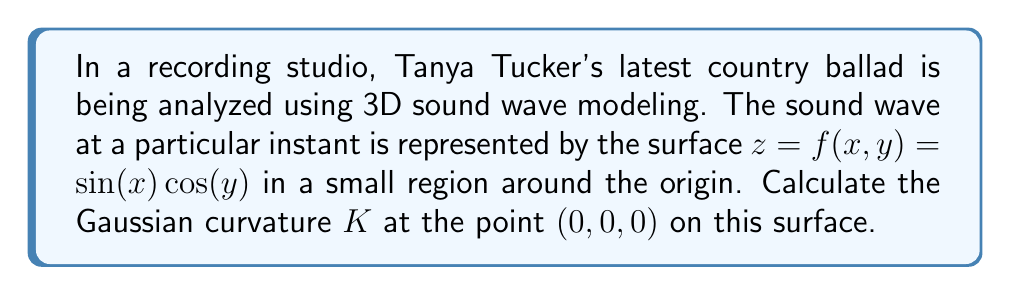Show me your answer to this math problem. To find the Gaussian curvature $K$ at the point $(0,0,0)$, we need to follow these steps:

1) The Gaussian curvature is given by $K = \frac{LN - M^2}{EG - F^2}$, where $L$, $M$, $N$ are coefficients of the second fundamental form, and $E$, $F$, $G$ are coefficients of the first fundamental form.

2) First, let's calculate the partial derivatives:
   $f_x = \cos(x)\cos(y)$
   $f_y = -\sin(x)\sin(y)$
   $f_{xx} = -\sin(x)\cos(y)$
   $f_{yy} = -\sin(x)\cos(y)$
   $f_{xy} = -\cos(x)\sin(y)$

3) At $(0,0,0)$:
   $f_x = 1$, $f_y = 0$, $f_{xx} = 0$, $f_{yy} = 0$, $f_{xy} = 0$

4) Calculate $E$, $F$, $G$:
   $E = 1 + f_x^2 = 2$
   $F = f_x f_y = 0$
   $G = 1 + f_y^2 = 1$

5) Calculate $L$, $M$, $N$:
   $L = \frac{f_{xx}}{\sqrt{1+f_x^2+f_y^2}} = 0$
   $M = \frac{f_{xy}}{\sqrt{1+f_x^2+f_y^2}} = 0$
   $N = \frac{f_{yy}}{\sqrt{1+f_x^2+f_y^2}} = 0$

6) Now we can calculate $K$:
   $$K = \frac{LN - M^2}{EG - F^2} = \frac{0 - 0}{2(1) - 0^2} = 0$$

Therefore, the Gaussian curvature at $(0,0,0)$ is 0.
Answer: $K = 0$ 